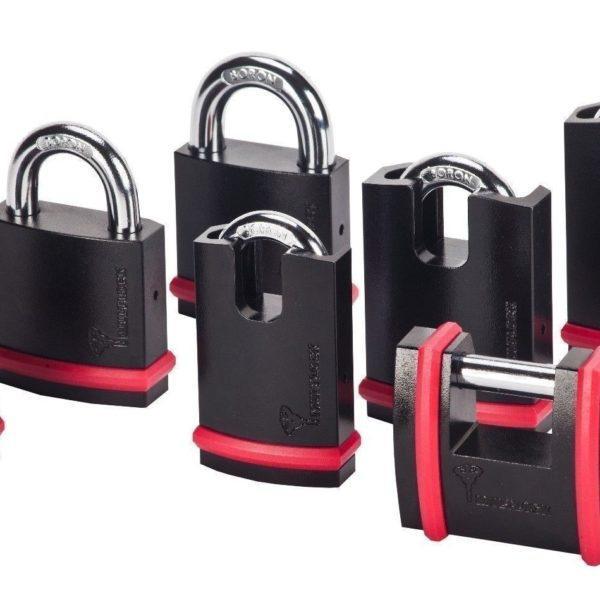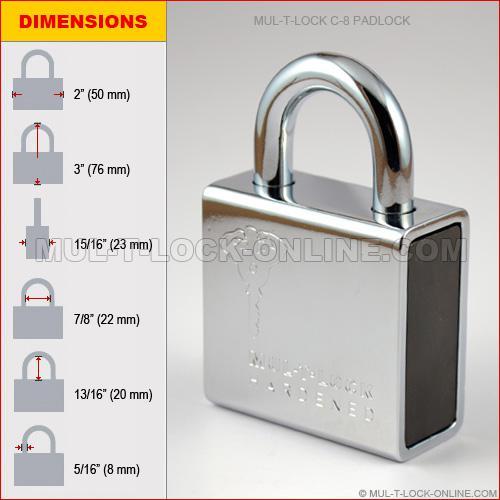The first image is the image on the left, the second image is the image on the right. Given the left and right images, does the statement "there are locks with color other than silver" hold true? Answer yes or no. Yes. 